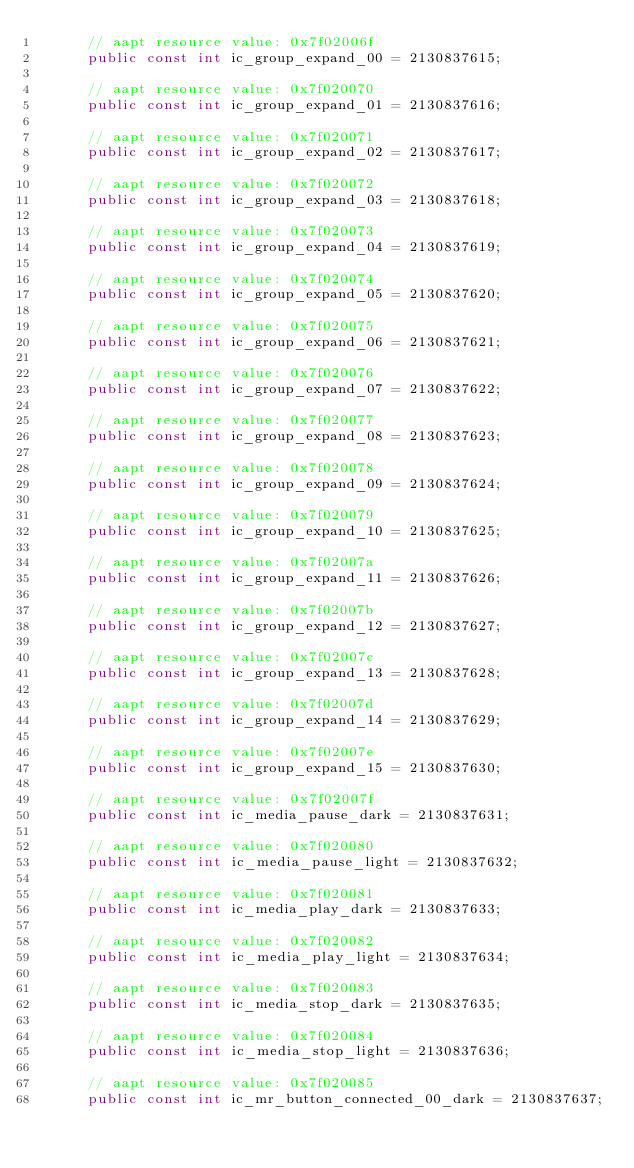Convert code to text. <code><loc_0><loc_0><loc_500><loc_500><_C#_>			// aapt resource value: 0x7f02006f
			public const int ic_group_expand_00 = 2130837615;
			
			// aapt resource value: 0x7f020070
			public const int ic_group_expand_01 = 2130837616;
			
			// aapt resource value: 0x7f020071
			public const int ic_group_expand_02 = 2130837617;
			
			// aapt resource value: 0x7f020072
			public const int ic_group_expand_03 = 2130837618;
			
			// aapt resource value: 0x7f020073
			public const int ic_group_expand_04 = 2130837619;
			
			// aapt resource value: 0x7f020074
			public const int ic_group_expand_05 = 2130837620;
			
			// aapt resource value: 0x7f020075
			public const int ic_group_expand_06 = 2130837621;
			
			// aapt resource value: 0x7f020076
			public const int ic_group_expand_07 = 2130837622;
			
			// aapt resource value: 0x7f020077
			public const int ic_group_expand_08 = 2130837623;
			
			// aapt resource value: 0x7f020078
			public const int ic_group_expand_09 = 2130837624;
			
			// aapt resource value: 0x7f020079
			public const int ic_group_expand_10 = 2130837625;
			
			// aapt resource value: 0x7f02007a
			public const int ic_group_expand_11 = 2130837626;
			
			// aapt resource value: 0x7f02007b
			public const int ic_group_expand_12 = 2130837627;
			
			// aapt resource value: 0x7f02007c
			public const int ic_group_expand_13 = 2130837628;
			
			// aapt resource value: 0x7f02007d
			public const int ic_group_expand_14 = 2130837629;
			
			// aapt resource value: 0x7f02007e
			public const int ic_group_expand_15 = 2130837630;
			
			// aapt resource value: 0x7f02007f
			public const int ic_media_pause_dark = 2130837631;
			
			// aapt resource value: 0x7f020080
			public const int ic_media_pause_light = 2130837632;
			
			// aapt resource value: 0x7f020081
			public const int ic_media_play_dark = 2130837633;
			
			// aapt resource value: 0x7f020082
			public const int ic_media_play_light = 2130837634;
			
			// aapt resource value: 0x7f020083
			public const int ic_media_stop_dark = 2130837635;
			
			// aapt resource value: 0x7f020084
			public const int ic_media_stop_light = 2130837636;
			
			// aapt resource value: 0x7f020085
			public const int ic_mr_button_connected_00_dark = 2130837637;
			</code> 